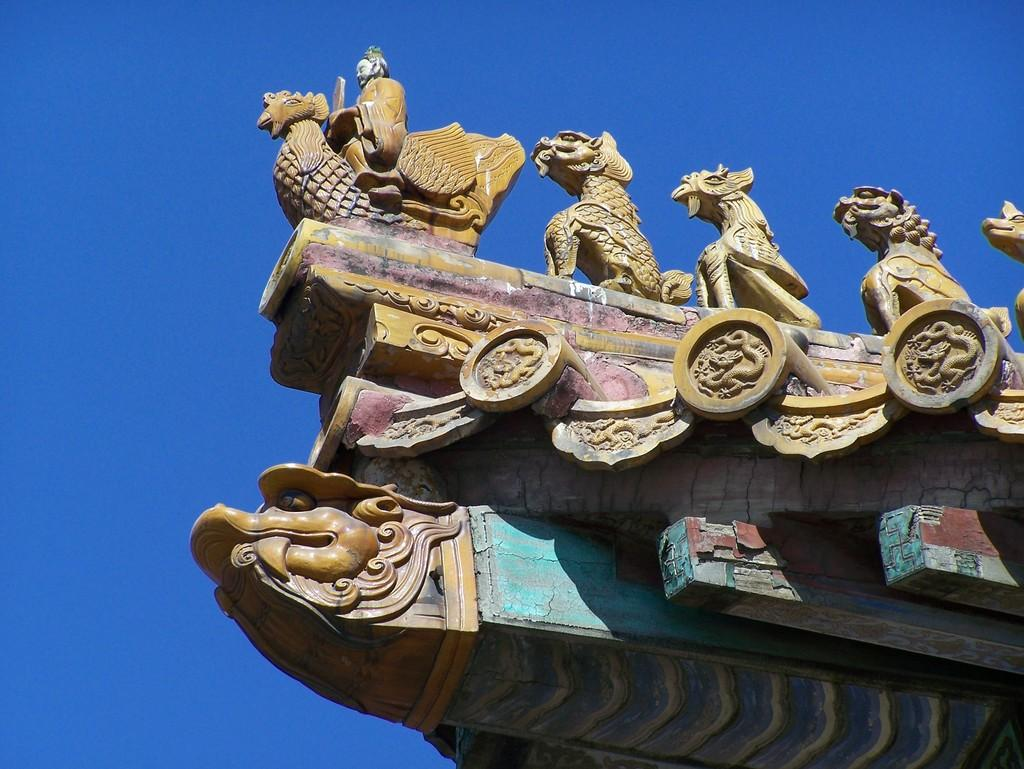What type of structure is present in the image? There is an arch in the image. Are there any decorations on the arch? Yes, the arch has sculptures on it. What can be seen in the background of the image? The background of the image includes a blue color sky. What letter is written on the coach in the image? There is no coach present in the image. What is the name of the person who created the sculptures on the arch? The provided facts do not mention the name of the person who created the sculptures on the arch. 